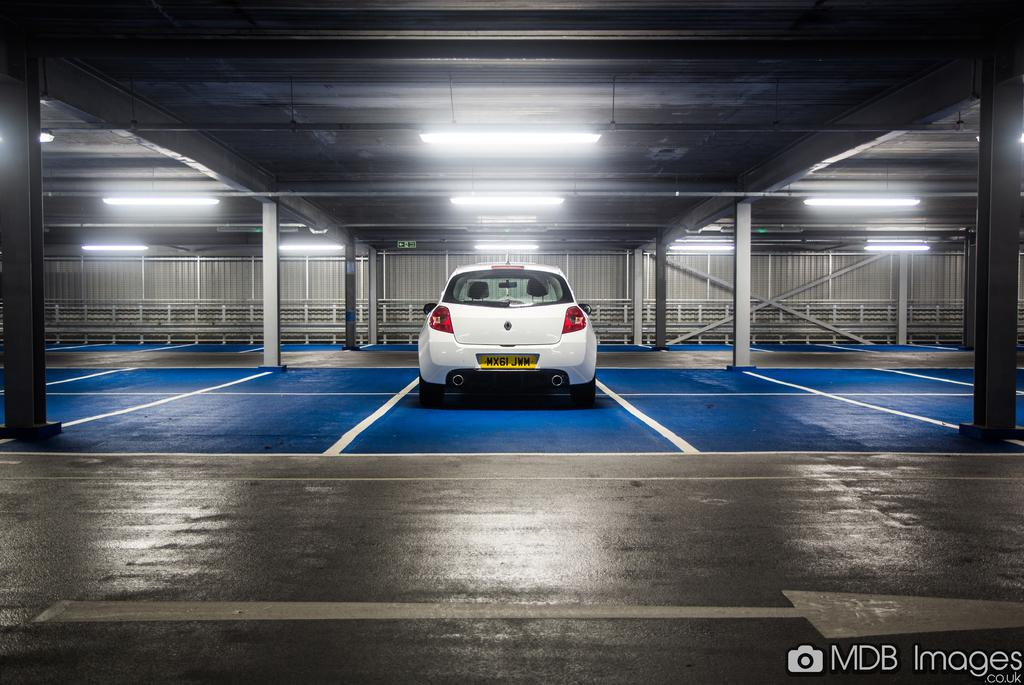What type of vehicle is in the image? There is a white car in the image. Where is the car located? The car is on the ground. Does the car have any identifying features? Yes, the car has a number plate and a rear light. Are there any additional lights on the car? Yes, there is a light above the rear light. What is the car's structure like? The car has a roof. What time of day is it at the lake in the image? There is no lake present in the image, and therefore no indication of the time of day. 